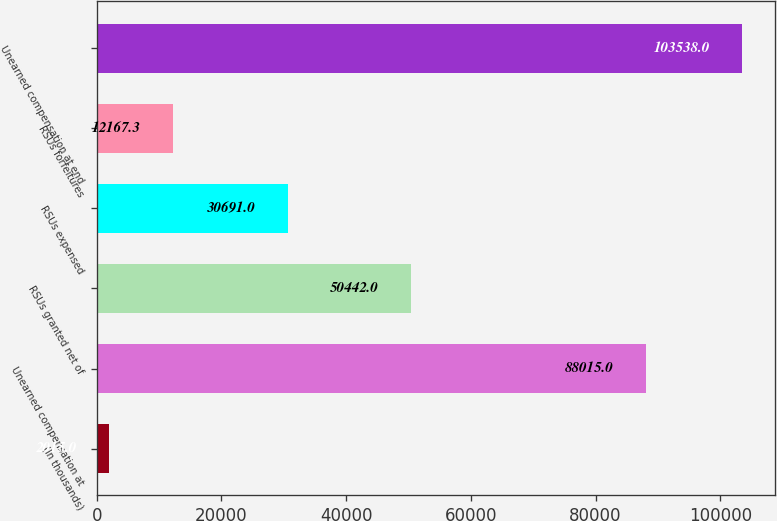Convert chart to OTSL. <chart><loc_0><loc_0><loc_500><loc_500><bar_chart><fcel>(In thousands)<fcel>Unearned compensation at<fcel>RSUs granted net of<fcel>RSUs expensed<fcel>RSUs forfeitures<fcel>Unearned compensation at end<nl><fcel>2015<fcel>88015<fcel>50442<fcel>30691<fcel>12167.3<fcel>103538<nl></chart> 